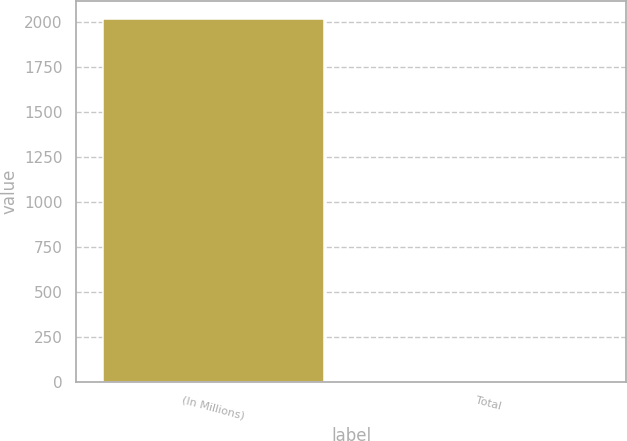Convert chart to OTSL. <chart><loc_0><loc_0><loc_500><loc_500><bar_chart><fcel>(In Millions)<fcel>Total<nl><fcel>2016<fcel>0.9<nl></chart> 